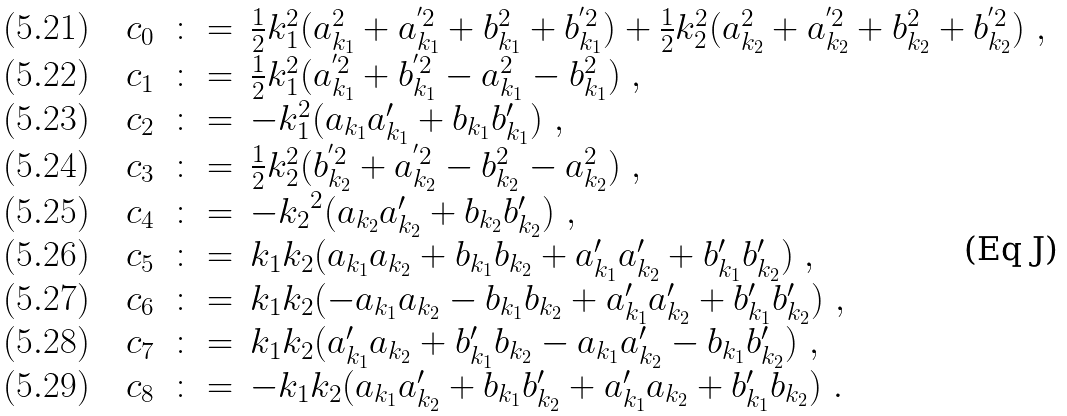Convert formula to latex. <formula><loc_0><loc_0><loc_500><loc_500>\begin{array} { l r c l } ( 5 . 2 1 ) \ \ & c _ { 0 } & \colon = & \frac { 1 } { 2 } k _ { 1 } ^ { 2 } ( a _ { k _ { 1 } } ^ { 2 } + a _ { k _ { 1 } } ^ { ^ { \prime } 2 } + b _ { k _ { 1 } } ^ { 2 } + b _ { k _ { 1 } } ^ { ^ { \prime } 2 } ) + \frac { 1 } { 2 } k _ { 2 } ^ { 2 } ( a _ { k _ { 2 } } ^ { 2 } + a _ { k _ { 2 } } ^ { ^ { \prime } 2 } + b _ { k _ { 2 } } ^ { 2 } + b _ { k _ { 2 } } ^ { ^ { \prime } 2 } ) \ , \\ ( 5 . 2 2 ) & c _ { 1 } & \colon = & \frac { 1 } { 2 } k _ { 1 } ^ { 2 } ( a _ { k _ { 1 } } ^ { ^ { \prime } 2 } + b _ { k _ { 1 } } ^ { ^ { \prime } 2 } - a _ { k _ { 1 } } ^ { 2 } - b _ { k _ { 1 } } ^ { 2 } ) \ , \\ ( 5 . 2 3 ) & c _ { 2 } & \colon = & - k _ { 1 } ^ { 2 } ( { a _ { k _ { 1 } } } { a _ { k _ { 1 } } ^ { \prime } } + { b _ { k _ { 1 } } } { b _ { k _ { 1 } } ^ { \prime } } ) \ , \\ ( 5 . 2 4 ) & c _ { 3 } & \colon = & \frac { 1 } { 2 } k _ { 2 } ^ { 2 } ( b _ { k _ { 2 } } ^ { ^ { \prime } 2 } + a _ { k _ { 2 } } ^ { ^ { \prime } 2 } - b _ { k _ { 2 } } ^ { 2 } - a _ { k _ { 2 } } ^ { 2 } ) \ , \\ ( 5 . 2 5 ) & c _ { 4 } & \colon = & - { k _ { 2 } } ^ { 2 } ( { a _ { k _ { 2 } } } { a _ { k _ { 2 } } ^ { \prime } } + { b _ { k _ { 2 } } } { b _ { k _ { 2 } } ^ { \prime } } ) \ , \\ ( 5 . 2 6 ) & c _ { 5 } & \colon = & { k _ { 1 } } { k _ { 2 } } ( { a _ { k _ { 1 } } } { a _ { k _ { 2 } } } + { b _ { k _ { 1 } } } { b _ { k _ { 2 } } } + { a _ { k _ { 1 } } ^ { \prime } } { a _ { k _ { 2 } } ^ { \prime } } + { b _ { k _ { 1 } } ^ { \prime } } { b _ { k _ { 2 } } ^ { \prime } } ) \ , \\ ( 5 . 2 7 ) & c _ { 6 } & \colon = & { k _ { 1 } } { k _ { 2 } } ( - { a _ { k _ { 1 } } } { a _ { k _ { 2 } } } - { b _ { k _ { 1 } } } { b _ { k _ { 2 } } } + { a _ { k _ { 1 } } ^ { \prime } } { a _ { k _ { 2 } } ^ { \prime } } + { b _ { k _ { 1 } } ^ { \prime } } { b _ { k _ { 2 } } ^ { \prime } } ) \ , \\ ( 5 . 2 8 ) & c _ { 7 } & \colon = & { k _ { 1 } } { k _ { 2 } } ( { a _ { k _ { 1 } } ^ { \prime } } { a _ { k _ { 2 } } } + { b _ { k _ { 1 } } ^ { \prime } } { b _ { k _ { 2 } } } - { a _ { k _ { 1 } } } { a _ { k _ { 2 } } ^ { \prime } } - { b _ { k _ { 1 } } } { b _ { k _ { 2 } } ^ { \prime } } ) \ , \\ ( 5 . 2 9 ) & c _ { 8 } & \colon = & - { k _ { 1 } } { k _ { 2 } } ( { a _ { k _ { 1 } } } { a _ { k _ { 2 } } ^ { \prime } } + { b _ { k _ { 1 } } } { b _ { k _ { 2 } } ^ { \prime } } + { a _ { k _ { 1 } } ^ { \prime } } { a _ { k _ { 2 } } } + { b _ { k _ { 1 } } ^ { \prime } } { b _ { k _ { 2 } } } ) \ . \end{array}</formula> 